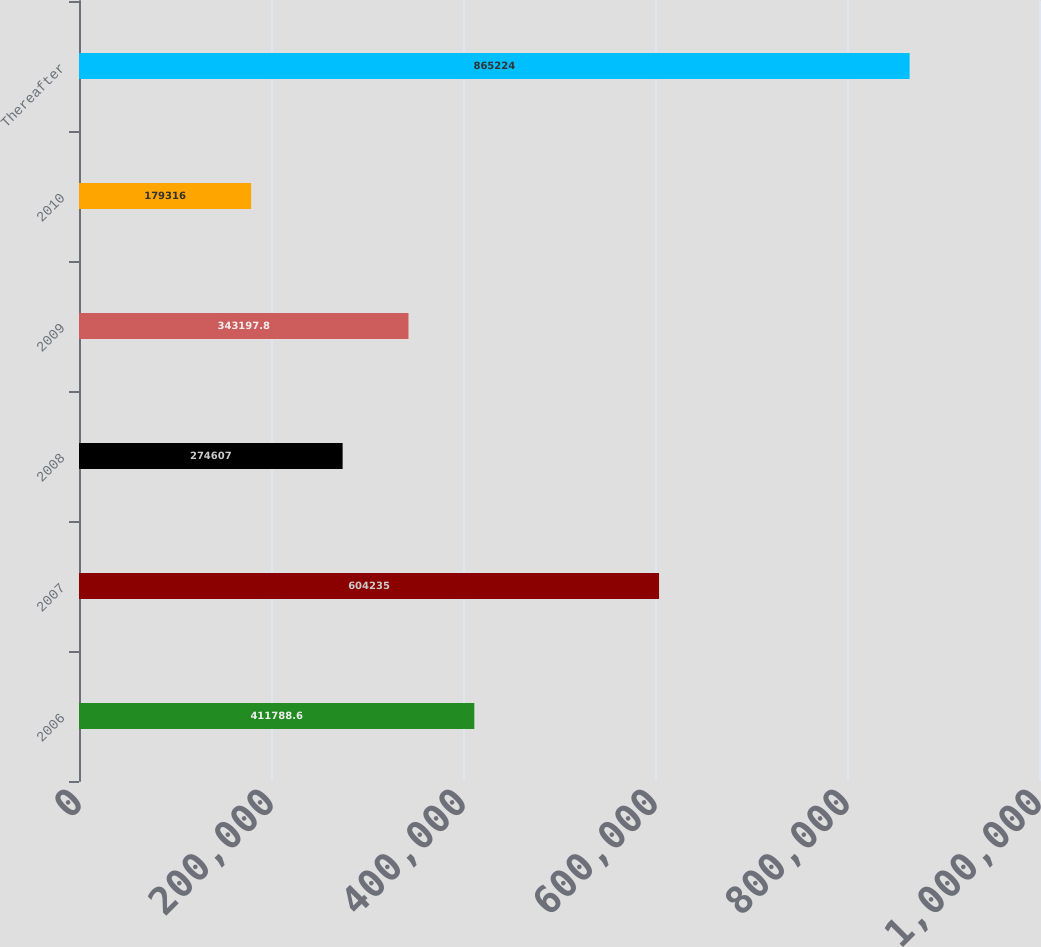<chart> <loc_0><loc_0><loc_500><loc_500><bar_chart><fcel>2006<fcel>2007<fcel>2008<fcel>2009<fcel>2010<fcel>Thereafter<nl><fcel>411789<fcel>604235<fcel>274607<fcel>343198<fcel>179316<fcel>865224<nl></chart> 